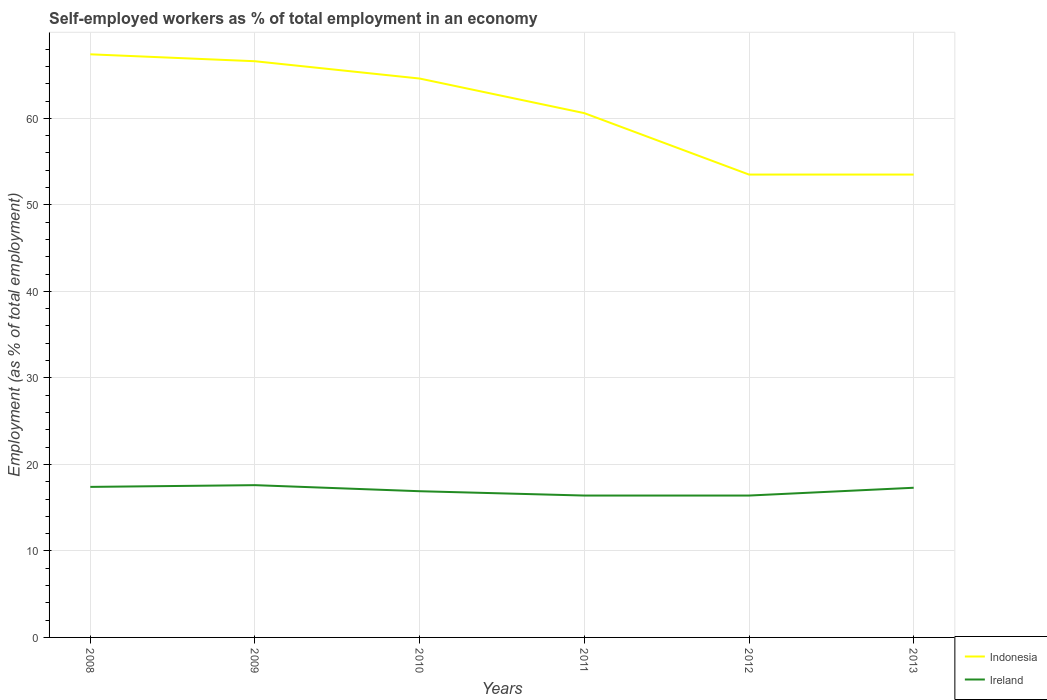Does the line corresponding to Indonesia intersect with the line corresponding to Ireland?
Your answer should be compact. No. Is the number of lines equal to the number of legend labels?
Your response must be concise. Yes. Across all years, what is the maximum percentage of self-employed workers in Ireland?
Make the answer very short. 16.4. In which year was the percentage of self-employed workers in Ireland maximum?
Ensure brevity in your answer.  2011. What is the total percentage of self-employed workers in Ireland in the graph?
Give a very brief answer. 1.2. What is the difference between the highest and the second highest percentage of self-employed workers in Ireland?
Your answer should be very brief. 1.2. What is the difference between the highest and the lowest percentage of self-employed workers in Indonesia?
Your response must be concise. 3. What is the difference between two consecutive major ticks on the Y-axis?
Offer a terse response. 10. Does the graph contain any zero values?
Give a very brief answer. No. What is the title of the graph?
Your answer should be compact. Self-employed workers as % of total employment in an economy. Does "Haiti" appear as one of the legend labels in the graph?
Ensure brevity in your answer.  No. What is the label or title of the X-axis?
Keep it short and to the point. Years. What is the label or title of the Y-axis?
Provide a succinct answer. Employment (as % of total employment). What is the Employment (as % of total employment) of Indonesia in 2008?
Provide a short and direct response. 67.4. What is the Employment (as % of total employment) in Ireland in 2008?
Your answer should be compact. 17.4. What is the Employment (as % of total employment) of Indonesia in 2009?
Provide a short and direct response. 66.6. What is the Employment (as % of total employment) in Ireland in 2009?
Make the answer very short. 17.6. What is the Employment (as % of total employment) in Indonesia in 2010?
Ensure brevity in your answer.  64.6. What is the Employment (as % of total employment) of Ireland in 2010?
Ensure brevity in your answer.  16.9. What is the Employment (as % of total employment) of Indonesia in 2011?
Your answer should be compact. 60.6. What is the Employment (as % of total employment) in Ireland in 2011?
Ensure brevity in your answer.  16.4. What is the Employment (as % of total employment) of Indonesia in 2012?
Keep it short and to the point. 53.5. What is the Employment (as % of total employment) in Ireland in 2012?
Keep it short and to the point. 16.4. What is the Employment (as % of total employment) in Indonesia in 2013?
Ensure brevity in your answer.  53.5. What is the Employment (as % of total employment) of Ireland in 2013?
Offer a terse response. 17.3. Across all years, what is the maximum Employment (as % of total employment) in Indonesia?
Your answer should be very brief. 67.4. Across all years, what is the maximum Employment (as % of total employment) of Ireland?
Your response must be concise. 17.6. Across all years, what is the minimum Employment (as % of total employment) of Indonesia?
Ensure brevity in your answer.  53.5. Across all years, what is the minimum Employment (as % of total employment) of Ireland?
Your answer should be very brief. 16.4. What is the total Employment (as % of total employment) of Indonesia in the graph?
Make the answer very short. 366.2. What is the total Employment (as % of total employment) of Ireland in the graph?
Offer a terse response. 102. What is the difference between the Employment (as % of total employment) in Indonesia in 2008 and that in 2009?
Offer a very short reply. 0.8. What is the difference between the Employment (as % of total employment) in Ireland in 2008 and that in 2010?
Provide a succinct answer. 0.5. What is the difference between the Employment (as % of total employment) in Indonesia in 2008 and that in 2012?
Your answer should be very brief. 13.9. What is the difference between the Employment (as % of total employment) in Indonesia in 2008 and that in 2013?
Ensure brevity in your answer.  13.9. What is the difference between the Employment (as % of total employment) of Ireland in 2009 and that in 2010?
Ensure brevity in your answer.  0.7. What is the difference between the Employment (as % of total employment) in Ireland in 2009 and that in 2011?
Make the answer very short. 1.2. What is the difference between the Employment (as % of total employment) of Indonesia in 2009 and that in 2013?
Ensure brevity in your answer.  13.1. What is the difference between the Employment (as % of total employment) of Ireland in 2009 and that in 2013?
Keep it short and to the point. 0.3. What is the difference between the Employment (as % of total employment) of Ireland in 2010 and that in 2011?
Provide a succinct answer. 0.5. What is the difference between the Employment (as % of total employment) of Indonesia in 2010 and that in 2012?
Your answer should be compact. 11.1. What is the difference between the Employment (as % of total employment) of Ireland in 2010 and that in 2012?
Ensure brevity in your answer.  0.5. What is the difference between the Employment (as % of total employment) of Indonesia in 2010 and that in 2013?
Your response must be concise. 11.1. What is the difference between the Employment (as % of total employment) of Ireland in 2010 and that in 2013?
Provide a succinct answer. -0.4. What is the difference between the Employment (as % of total employment) of Indonesia in 2011 and that in 2012?
Make the answer very short. 7.1. What is the difference between the Employment (as % of total employment) in Indonesia in 2008 and the Employment (as % of total employment) in Ireland in 2009?
Your response must be concise. 49.8. What is the difference between the Employment (as % of total employment) in Indonesia in 2008 and the Employment (as % of total employment) in Ireland in 2010?
Give a very brief answer. 50.5. What is the difference between the Employment (as % of total employment) in Indonesia in 2008 and the Employment (as % of total employment) in Ireland in 2012?
Make the answer very short. 51. What is the difference between the Employment (as % of total employment) in Indonesia in 2008 and the Employment (as % of total employment) in Ireland in 2013?
Provide a short and direct response. 50.1. What is the difference between the Employment (as % of total employment) in Indonesia in 2009 and the Employment (as % of total employment) in Ireland in 2010?
Give a very brief answer. 49.7. What is the difference between the Employment (as % of total employment) of Indonesia in 2009 and the Employment (as % of total employment) of Ireland in 2011?
Your answer should be compact. 50.2. What is the difference between the Employment (as % of total employment) of Indonesia in 2009 and the Employment (as % of total employment) of Ireland in 2012?
Offer a very short reply. 50.2. What is the difference between the Employment (as % of total employment) in Indonesia in 2009 and the Employment (as % of total employment) in Ireland in 2013?
Ensure brevity in your answer.  49.3. What is the difference between the Employment (as % of total employment) of Indonesia in 2010 and the Employment (as % of total employment) of Ireland in 2011?
Make the answer very short. 48.2. What is the difference between the Employment (as % of total employment) of Indonesia in 2010 and the Employment (as % of total employment) of Ireland in 2012?
Make the answer very short. 48.2. What is the difference between the Employment (as % of total employment) of Indonesia in 2010 and the Employment (as % of total employment) of Ireland in 2013?
Offer a terse response. 47.3. What is the difference between the Employment (as % of total employment) of Indonesia in 2011 and the Employment (as % of total employment) of Ireland in 2012?
Offer a very short reply. 44.2. What is the difference between the Employment (as % of total employment) in Indonesia in 2011 and the Employment (as % of total employment) in Ireland in 2013?
Keep it short and to the point. 43.3. What is the difference between the Employment (as % of total employment) in Indonesia in 2012 and the Employment (as % of total employment) in Ireland in 2013?
Provide a succinct answer. 36.2. What is the average Employment (as % of total employment) in Indonesia per year?
Offer a very short reply. 61.03. What is the average Employment (as % of total employment) of Ireland per year?
Your answer should be very brief. 17. In the year 2009, what is the difference between the Employment (as % of total employment) in Indonesia and Employment (as % of total employment) in Ireland?
Your response must be concise. 49. In the year 2010, what is the difference between the Employment (as % of total employment) in Indonesia and Employment (as % of total employment) in Ireland?
Ensure brevity in your answer.  47.7. In the year 2011, what is the difference between the Employment (as % of total employment) in Indonesia and Employment (as % of total employment) in Ireland?
Your response must be concise. 44.2. In the year 2012, what is the difference between the Employment (as % of total employment) of Indonesia and Employment (as % of total employment) of Ireland?
Provide a short and direct response. 37.1. In the year 2013, what is the difference between the Employment (as % of total employment) of Indonesia and Employment (as % of total employment) of Ireland?
Keep it short and to the point. 36.2. What is the ratio of the Employment (as % of total employment) in Ireland in 2008 to that in 2009?
Provide a short and direct response. 0.99. What is the ratio of the Employment (as % of total employment) of Indonesia in 2008 to that in 2010?
Ensure brevity in your answer.  1.04. What is the ratio of the Employment (as % of total employment) of Ireland in 2008 to that in 2010?
Offer a terse response. 1.03. What is the ratio of the Employment (as % of total employment) of Indonesia in 2008 to that in 2011?
Your answer should be very brief. 1.11. What is the ratio of the Employment (as % of total employment) of Ireland in 2008 to that in 2011?
Offer a very short reply. 1.06. What is the ratio of the Employment (as % of total employment) in Indonesia in 2008 to that in 2012?
Provide a short and direct response. 1.26. What is the ratio of the Employment (as % of total employment) of Ireland in 2008 to that in 2012?
Make the answer very short. 1.06. What is the ratio of the Employment (as % of total employment) of Indonesia in 2008 to that in 2013?
Give a very brief answer. 1.26. What is the ratio of the Employment (as % of total employment) in Indonesia in 2009 to that in 2010?
Make the answer very short. 1.03. What is the ratio of the Employment (as % of total employment) in Ireland in 2009 to that in 2010?
Provide a short and direct response. 1.04. What is the ratio of the Employment (as % of total employment) of Indonesia in 2009 to that in 2011?
Provide a succinct answer. 1.1. What is the ratio of the Employment (as % of total employment) in Ireland in 2009 to that in 2011?
Your answer should be very brief. 1.07. What is the ratio of the Employment (as % of total employment) of Indonesia in 2009 to that in 2012?
Offer a very short reply. 1.24. What is the ratio of the Employment (as % of total employment) of Ireland in 2009 to that in 2012?
Ensure brevity in your answer.  1.07. What is the ratio of the Employment (as % of total employment) in Indonesia in 2009 to that in 2013?
Your response must be concise. 1.24. What is the ratio of the Employment (as % of total employment) of Ireland in 2009 to that in 2013?
Your response must be concise. 1.02. What is the ratio of the Employment (as % of total employment) in Indonesia in 2010 to that in 2011?
Make the answer very short. 1.07. What is the ratio of the Employment (as % of total employment) in Ireland in 2010 to that in 2011?
Provide a succinct answer. 1.03. What is the ratio of the Employment (as % of total employment) in Indonesia in 2010 to that in 2012?
Offer a very short reply. 1.21. What is the ratio of the Employment (as % of total employment) of Ireland in 2010 to that in 2012?
Ensure brevity in your answer.  1.03. What is the ratio of the Employment (as % of total employment) of Indonesia in 2010 to that in 2013?
Make the answer very short. 1.21. What is the ratio of the Employment (as % of total employment) in Ireland in 2010 to that in 2013?
Provide a succinct answer. 0.98. What is the ratio of the Employment (as % of total employment) of Indonesia in 2011 to that in 2012?
Make the answer very short. 1.13. What is the ratio of the Employment (as % of total employment) of Ireland in 2011 to that in 2012?
Your answer should be very brief. 1. What is the ratio of the Employment (as % of total employment) in Indonesia in 2011 to that in 2013?
Give a very brief answer. 1.13. What is the ratio of the Employment (as % of total employment) in Ireland in 2011 to that in 2013?
Offer a terse response. 0.95. What is the ratio of the Employment (as % of total employment) of Indonesia in 2012 to that in 2013?
Give a very brief answer. 1. What is the ratio of the Employment (as % of total employment) of Ireland in 2012 to that in 2013?
Offer a terse response. 0.95. What is the difference between the highest and the second highest Employment (as % of total employment) of Indonesia?
Ensure brevity in your answer.  0.8. What is the difference between the highest and the second highest Employment (as % of total employment) of Ireland?
Give a very brief answer. 0.2. What is the difference between the highest and the lowest Employment (as % of total employment) in Indonesia?
Make the answer very short. 13.9. What is the difference between the highest and the lowest Employment (as % of total employment) in Ireland?
Give a very brief answer. 1.2. 